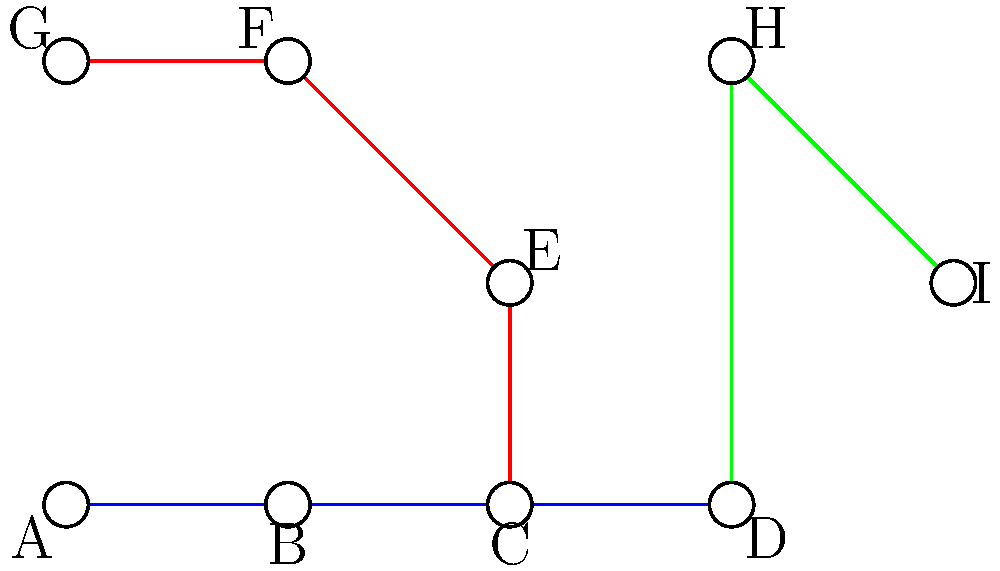Consider the simplified topological representation of the BART system above. How many stations in this map have a degree (number of connecting lines) greater than 2? To solve this problem, we need to count the number of stations that have more than two connecting lines. Let's examine each station:

1. Station A: 1 connection (degree 1)
2. Station B: 2 connections (degree 2)
3. Station C: 3 connections (degree 3)
4. Station D: 2 connections (degree 2)
5. Station E: 2 connections (degree 2)
6. Station F: 2 connections (degree 2)
7. Station G: 1 connection (degree 1)
8. Station H: 2 connections (degree 2)
9. Station I: 1 connection (degree 1)

From this analysis, we can see that only Station C has a degree greater than 2. It has 3 connecting lines (blue, red, and green).

Therefore, there is only 1 station in this simplified BART map representation that has a degree greater than 2.
Answer: 1 